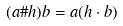Convert formula to latex. <formula><loc_0><loc_0><loc_500><loc_500>( a \# h ) b = a ( h \cdot b )</formula> 